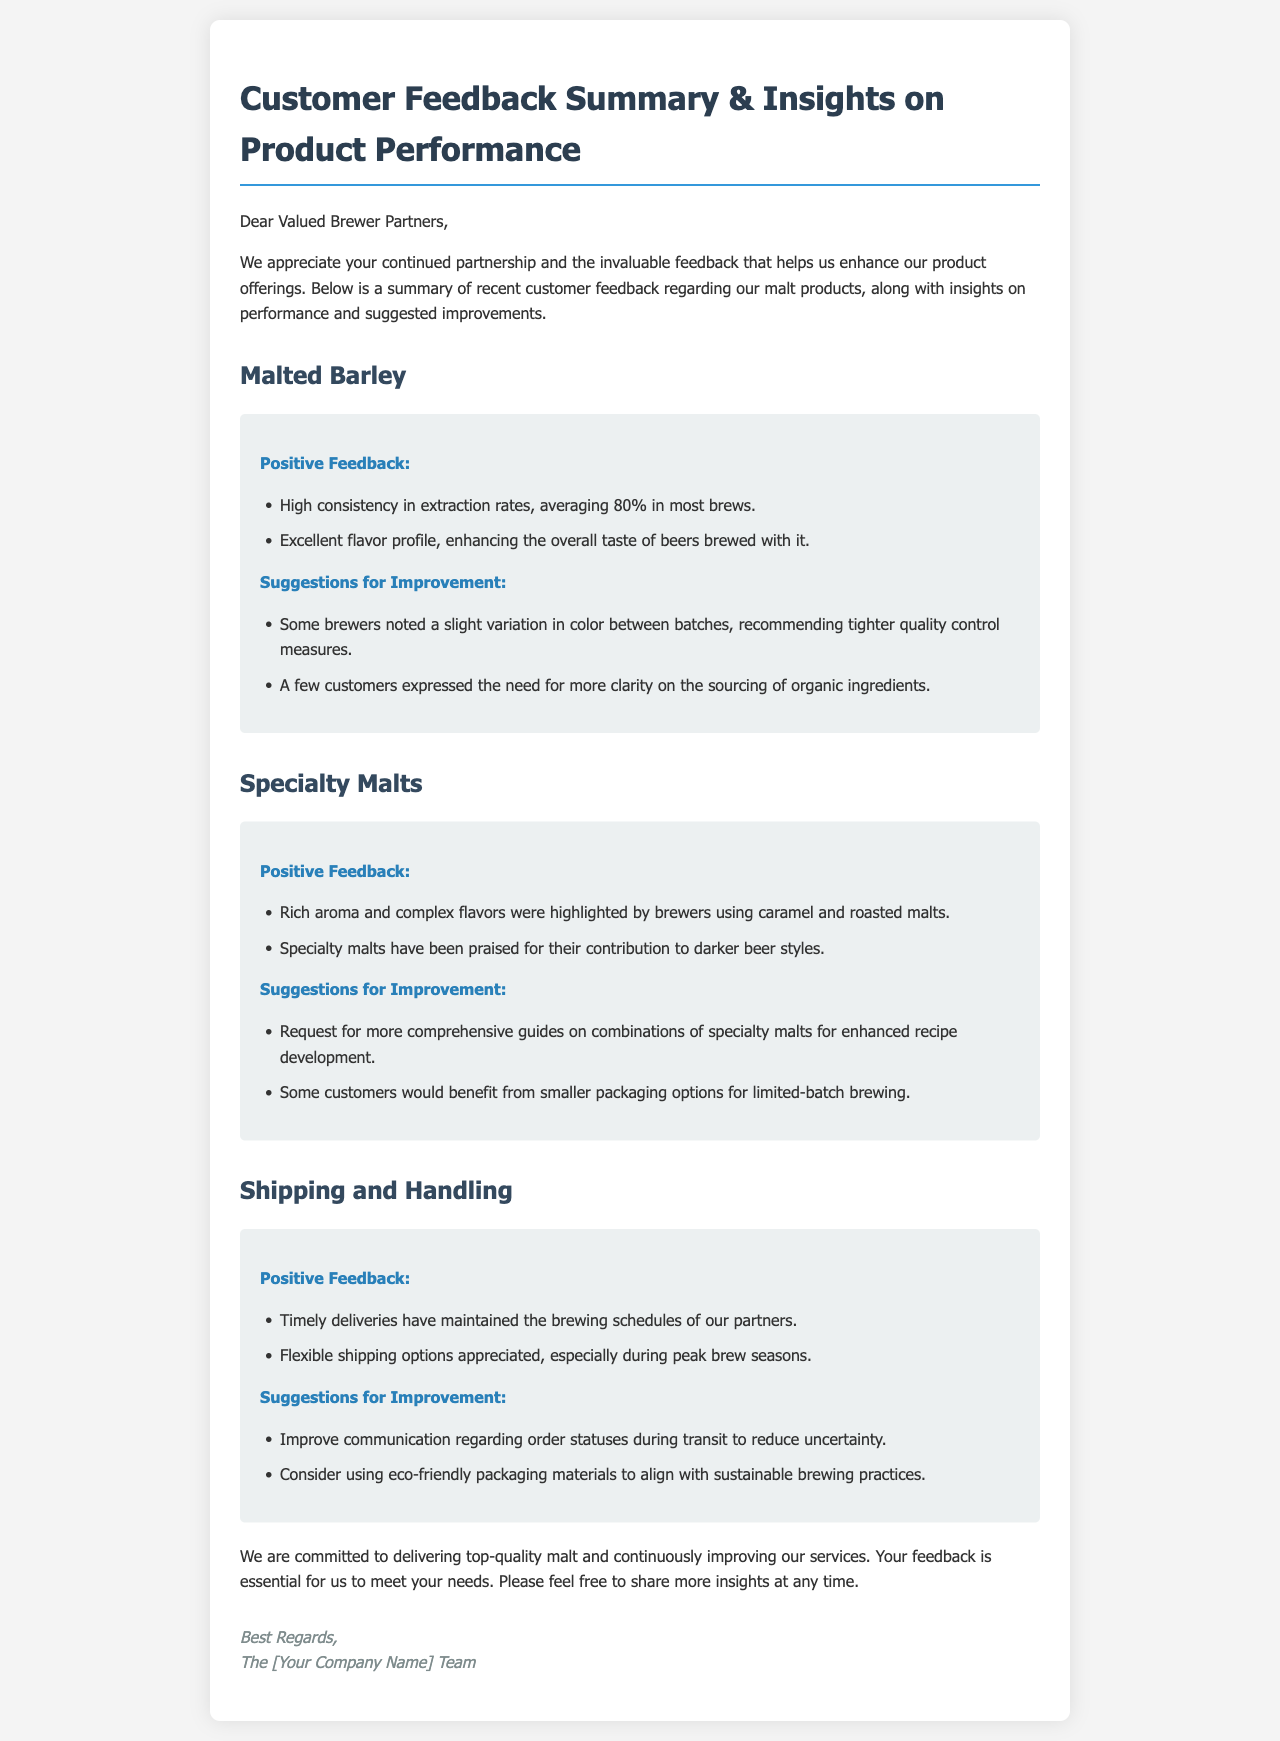What is the average extraction rate for malted barley? The document states that the average extraction rate for malted barley is 80% in most brews.
Answer: 80% What feedback was received regarding specialty malts? The feedback highlights that rich aroma and complex flavors were praised by brewers using specialty malts.
Answer: Rich aroma and complex flavors What are suggested improvements for shipping? Suggestions for improvement regarding shipping include better communication on order statuses and using eco-friendly packaging.
Answer: Improve communication regarding order statuses and consider using eco-friendly packaging materials What reason did some customers give for wanting smaller packaging options? Some customers expressed a need for smaller packaging options for limited-batch brewing.
Answer: Limited-batch brewing What topic was addressed in the section about malted barley? The topic addressed in the section about malted barley includes both positive feedback and suggestions for improvement.
Answer: Positive feedback and suggestions for improvement How did brewers respond to the flavor profile of malted barley? Brewers responded positively, stating that malted barley enhances the overall taste of beers brewed with it.
Answer: Enhancing the overall taste of beers What aspect of specialty malts contributed to their praise in darker beer styles? Specialty malts were praised for their contribution to darker beer styles.
Answer: Contribution to darker beer styles Who is the document addressed to? The document is addressed to "Valued Brewer Partners."
Answer: Valued Brewer Partners 